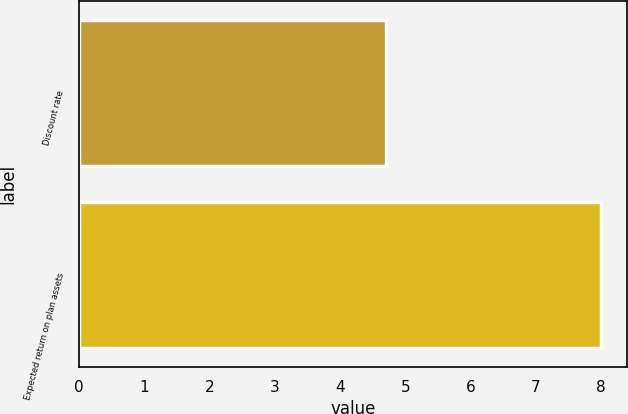Convert chart. <chart><loc_0><loc_0><loc_500><loc_500><bar_chart><fcel>Discount rate<fcel>Expected return on plan assets<nl><fcel>4.7<fcel>8<nl></chart> 